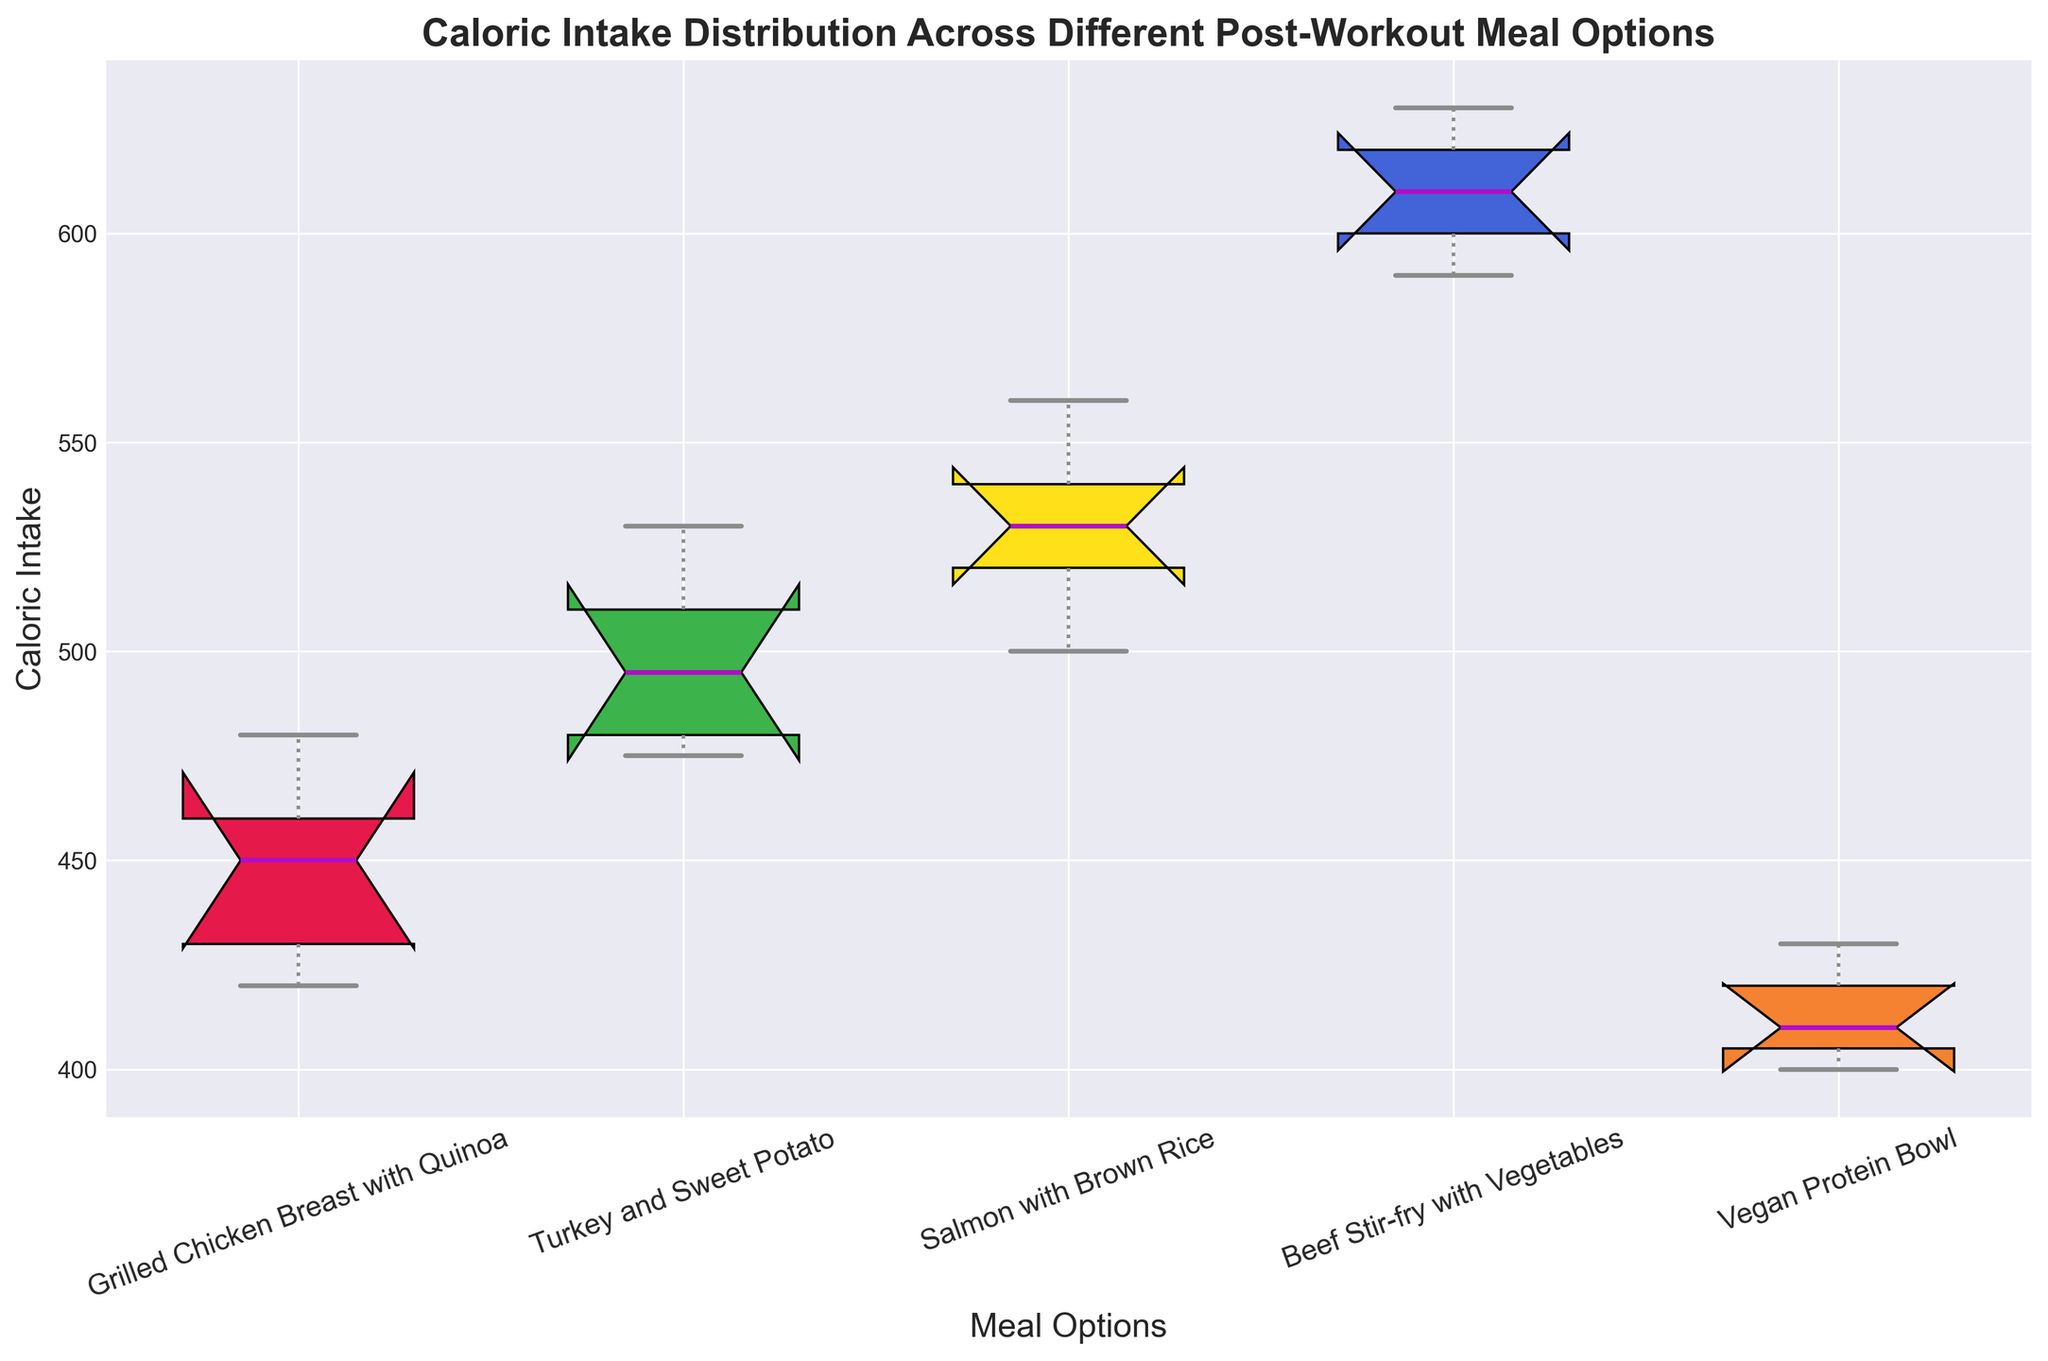Which meal option has the highest median caloric intake? To answer this, look at the horizontal line in the middle of each box. The highest median caloric intake corresponds to the highest horizontal line.
Answer: Beef Stir-fry with Vegetables Which meal option has the lowest median caloric intake? Look for the meal option with the lowest horizontal line in the center of the box.
Answer: Vegan Protein Bowl What is the interquartile range (IQR) for the Salmon with Brown Rice option? The IQR is calculated by subtracting the lower quartile (bottom of the box) from the upper quartile (top of the box). Identify these positions visually in the box plot of the Salmon with Brown Rice.
Answer: 40 Is the median caloric intake of Grilled Chicken Breast with Quinoa higher or lower than that of Turkey and Sweet Potato? Compare the horizontal lines inside the boxes of the two meal options to determine which is higher.
Answer: Lower Which meal option shows the widest spread in caloric intake? The spread is identified by the length of the box and whiskers. The wider the spread, the more varied the caloric intake.
Answer: Beef Stir-fry with Vegetables How does the caloric intake variability of the Turkey and Sweet Potato compare to the Vegan Protein Bowl? To compare variability, look at the length of the boxes and whiskers. The longer they are, the greater the variability.
Answer: Turkey and Sweet Potato has greater variability Which meal options have any outliers? Outliers are identified by points outside the whiskers. Look for any dots separated from the main part of the boxes.
Answer: None What is the range of caloric intake for Beef Stir-fry with Vegetables? The range is the difference between the highest and lowest whisker ends for the Beef Stir-fry with Vegetables box.
Answer: 40 